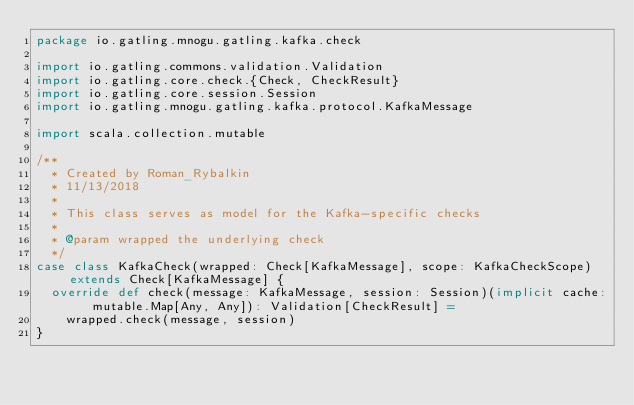<code> <loc_0><loc_0><loc_500><loc_500><_Scala_>package io.gatling.mnogu.gatling.kafka.check

import io.gatling.commons.validation.Validation
import io.gatling.core.check.{Check, CheckResult}
import io.gatling.core.session.Session
import io.gatling.mnogu.gatling.kafka.protocol.KafkaMessage

import scala.collection.mutable

/**
  * Created by Roman_Rybalkin 
  * 11/13/2018
  *
  * This class serves as model for the Kafka-specific checks
  *
  * @param wrapped the underlying check
  */
case class KafkaCheck(wrapped: Check[KafkaMessage], scope: KafkaCheckScope) extends Check[KafkaMessage] {
  override def check(message: KafkaMessage, session: Session)(implicit cache: mutable.Map[Any, Any]): Validation[CheckResult] =
    wrapped.check(message, session)
}
</code> 